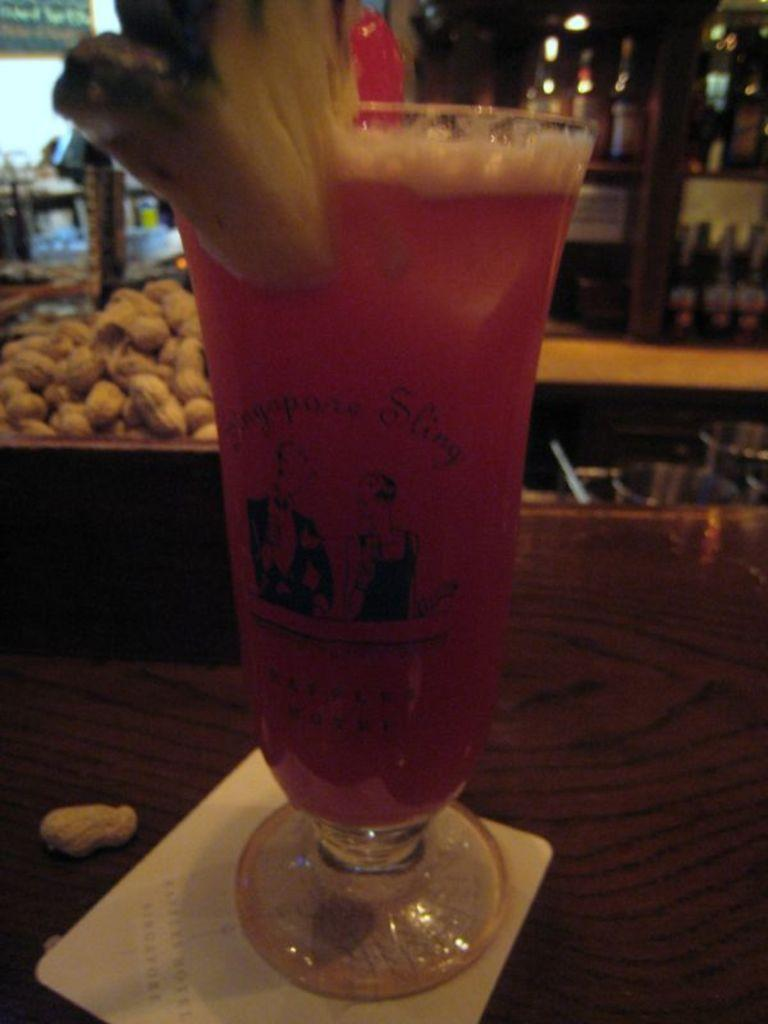What type of glass can be seen in the image? There is a wine glass in the image. What is present on the right side of the image? There are peanut shells on the right side of the image. What piece of furniture is visible in the image? There is a table in the image. Where are the alcohol bottles located in the image? The alcohol bottles are on a rack in the image. What type of pest can be seen crawling on the table in the image? There is no pest visible in the image; it only features a wine glass, peanut shells, a table, and alcohol bottles on a rack. 